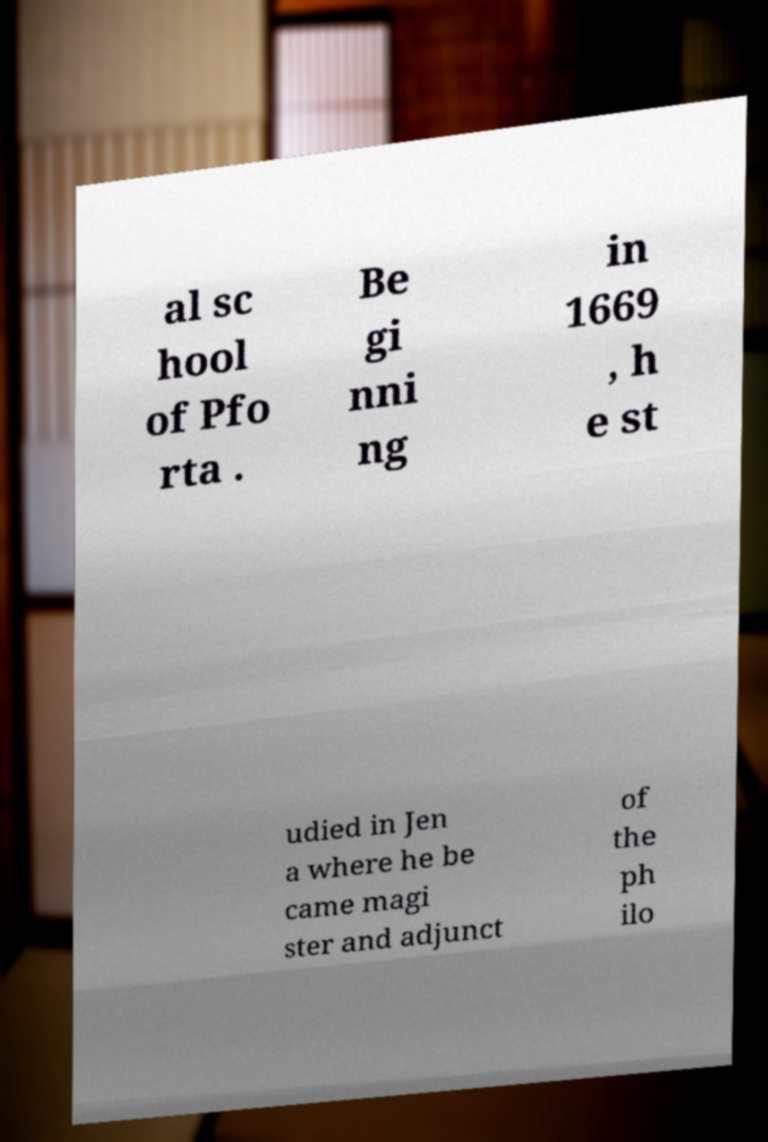Please identify and transcribe the text found in this image. al sc hool of Pfo rta . Be gi nni ng in 1669 , h e st udied in Jen a where he be came magi ster and adjunct of the ph ilo 